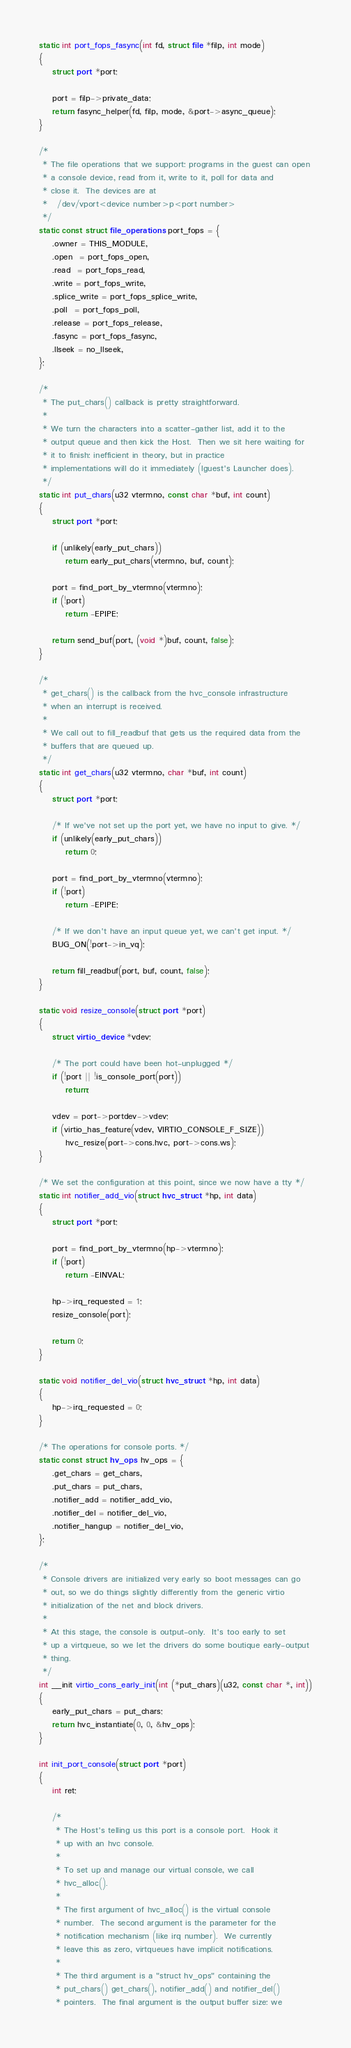<code> <loc_0><loc_0><loc_500><loc_500><_C_>static int port_fops_fasync(int fd, struct file *filp, int mode)
{
	struct port *port;

	port = filp->private_data;
	return fasync_helper(fd, filp, mode, &port->async_queue);
}

/*
 * The file operations that we support: programs in the guest can open
 * a console device, read from it, write to it, poll for data and
 * close it.  The devices are at
 *   /dev/vport<device number>p<port number>
 */
static const struct file_operations port_fops = {
	.owner = THIS_MODULE,
	.open  = port_fops_open,
	.read  = port_fops_read,
	.write = port_fops_write,
	.splice_write = port_fops_splice_write,
	.poll  = port_fops_poll,
	.release = port_fops_release,
	.fasync = port_fops_fasync,
	.llseek = no_llseek,
};

/*
 * The put_chars() callback is pretty straightforward.
 *
 * We turn the characters into a scatter-gather list, add it to the
 * output queue and then kick the Host.  Then we sit here waiting for
 * it to finish: inefficient in theory, but in practice
 * implementations will do it immediately (lguest's Launcher does).
 */
static int put_chars(u32 vtermno, const char *buf, int count)
{
	struct port *port;

	if (unlikely(early_put_chars))
		return early_put_chars(vtermno, buf, count);

	port = find_port_by_vtermno(vtermno);
	if (!port)
		return -EPIPE;

	return send_buf(port, (void *)buf, count, false);
}

/*
 * get_chars() is the callback from the hvc_console infrastructure
 * when an interrupt is received.
 *
 * We call out to fill_readbuf that gets us the required data from the
 * buffers that are queued up.
 */
static int get_chars(u32 vtermno, char *buf, int count)
{
	struct port *port;

	/* If we've not set up the port yet, we have no input to give. */
	if (unlikely(early_put_chars))
		return 0;

	port = find_port_by_vtermno(vtermno);
	if (!port)
		return -EPIPE;

	/* If we don't have an input queue yet, we can't get input. */
	BUG_ON(!port->in_vq);

	return fill_readbuf(port, buf, count, false);
}

static void resize_console(struct port *port)
{
	struct virtio_device *vdev;

	/* The port could have been hot-unplugged */
	if (!port || !is_console_port(port))
		return;

	vdev = port->portdev->vdev;
	if (virtio_has_feature(vdev, VIRTIO_CONSOLE_F_SIZE))
		hvc_resize(port->cons.hvc, port->cons.ws);
}

/* We set the configuration at this point, since we now have a tty */
static int notifier_add_vio(struct hvc_struct *hp, int data)
{
	struct port *port;

	port = find_port_by_vtermno(hp->vtermno);
	if (!port)
		return -EINVAL;

	hp->irq_requested = 1;
	resize_console(port);

	return 0;
}

static void notifier_del_vio(struct hvc_struct *hp, int data)
{
	hp->irq_requested = 0;
}

/* The operations for console ports. */
static const struct hv_ops hv_ops = {
	.get_chars = get_chars,
	.put_chars = put_chars,
	.notifier_add = notifier_add_vio,
	.notifier_del = notifier_del_vio,
	.notifier_hangup = notifier_del_vio,
};

/*
 * Console drivers are initialized very early so boot messages can go
 * out, so we do things slightly differently from the generic virtio
 * initialization of the net and block drivers.
 *
 * At this stage, the console is output-only.  It's too early to set
 * up a virtqueue, so we let the drivers do some boutique early-output
 * thing.
 */
int __init virtio_cons_early_init(int (*put_chars)(u32, const char *, int))
{
	early_put_chars = put_chars;
	return hvc_instantiate(0, 0, &hv_ops);
}

int init_port_console(struct port *port)
{
	int ret;

	/*
	 * The Host's telling us this port is a console port.  Hook it
	 * up with an hvc console.
	 *
	 * To set up and manage our virtual console, we call
	 * hvc_alloc().
	 *
	 * The first argument of hvc_alloc() is the virtual console
	 * number.  The second argument is the parameter for the
	 * notification mechanism (like irq number).  We currently
	 * leave this as zero, virtqueues have implicit notifications.
	 *
	 * The third argument is a "struct hv_ops" containing the
	 * put_chars() get_chars(), notifier_add() and notifier_del()
	 * pointers.  The final argument is the output buffer size: we</code> 